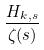<formula> <loc_0><loc_0><loc_500><loc_500>\frac { H _ { k , s } } { \zeta ( s ) }</formula> 